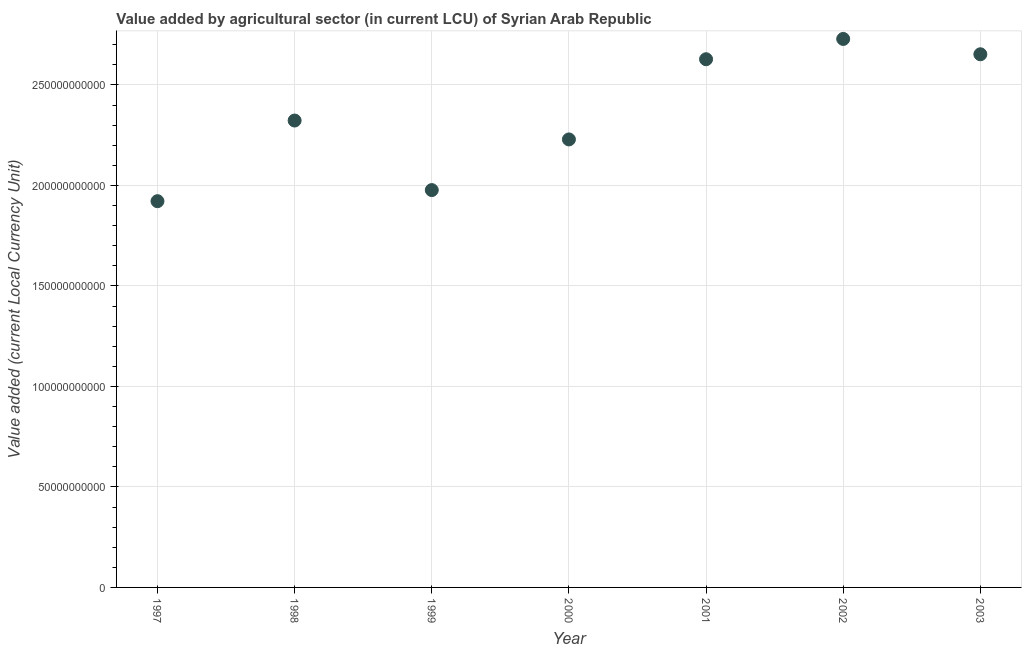What is the value added by agriculture sector in 2000?
Ensure brevity in your answer.  2.23e+11. Across all years, what is the maximum value added by agriculture sector?
Offer a very short reply. 2.73e+11. Across all years, what is the minimum value added by agriculture sector?
Your answer should be compact. 1.92e+11. In which year was the value added by agriculture sector maximum?
Provide a succinct answer. 2002. What is the sum of the value added by agriculture sector?
Make the answer very short. 1.65e+12. What is the difference between the value added by agriculture sector in 1998 and 2002?
Provide a short and direct response. -4.06e+1. What is the average value added by agriculture sector per year?
Keep it short and to the point. 2.35e+11. What is the median value added by agriculture sector?
Your response must be concise. 2.32e+11. In how many years, is the value added by agriculture sector greater than 260000000000 LCU?
Ensure brevity in your answer.  3. What is the ratio of the value added by agriculture sector in 1998 to that in 2001?
Offer a terse response. 0.88. Is the value added by agriculture sector in 2001 less than that in 2003?
Provide a succinct answer. Yes. Is the difference between the value added by agriculture sector in 1997 and 2002 greater than the difference between any two years?
Your answer should be compact. Yes. What is the difference between the highest and the second highest value added by agriculture sector?
Offer a very short reply. 7.63e+09. What is the difference between the highest and the lowest value added by agriculture sector?
Keep it short and to the point. 8.07e+1. Does the value added by agriculture sector monotonically increase over the years?
Make the answer very short. No. How many dotlines are there?
Offer a terse response. 1. Are the values on the major ticks of Y-axis written in scientific E-notation?
Offer a terse response. No. What is the title of the graph?
Provide a short and direct response. Value added by agricultural sector (in current LCU) of Syrian Arab Republic. What is the label or title of the Y-axis?
Provide a short and direct response. Value added (current Local Currency Unit). What is the Value added (current Local Currency Unit) in 1997?
Your answer should be compact. 1.92e+11. What is the Value added (current Local Currency Unit) in 1998?
Give a very brief answer. 2.32e+11. What is the Value added (current Local Currency Unit) in 1999?
Your answer should be compact. 1.98e+11. What is the Value added (current Local Currency Unit) in 2000?
Make the answer very short. 2.23e+11. What is the Value added (current Local Currency Unit) in 2001?
Ensure brevity in your answer.  2.63e+11. What is the Value added (current Local Currency Unit) in 2002?
Provide a short and direct response. 2.73e+11. What is the Value added (current Local Currency Unit) in 2003?
Keep it short and to the point. 2.65e+11. What is the difference between the Value added (current Local Currency Unit) in 1997 and 1998?
Give a very brief answer. -4.01e+1. What is the difference between the Value added (current Local Currency Unit) in 1997 and 1999?
Offer a terse response. -5.52e+09. What is the difference between the Value added (current Local Currency Unit) in 1997 and 2000?
Keep it short and to the point. -3.07e+1. What is the difference between the Value added (current Local Currency Unit) in 1997 and 2001?
Offer a very short reply. -7.06e+1. What is the difference between the Value added (current Local Currency Unit) in 1997 and 2002?
Ensure brevity in your answer.  -8.07e+1. What is the difference between the Value added (current Local Currency Unit) in 1997 and 2003?
Your answer should be compact. -7.31e+1. What is the difference between the Value added (current Local Currency Unit) in 1998 and 1999?
Ensure brevity in your answer.  3.46e+1. What is the difference between the Value added (current Local Currency Unit) in 1998 and 2000?
Provide a short and direct response. 9.40e+09. What is the difference between the Value added (current Local Currency Unit) in 1998 and 2001?
Offer a very short reply. -3.05e+1. What is the difference between the Value added (current Local Currency Unit) in 1998 and 2002?
Keep it short and to the point. -4.06e+1. What is the difference between the Value added (current Local Currency Unit) in 1998 and 2003?
Offer a very short reply. -3.30e+1. What is the difference between the Value added (current Local Currency Unit) in 1999 and 2000?
Make the answer very short. -2.52e+1. What is the difference between the Value added (current Local Currency Unit) in 1999 and 2001?
Offer a very short reply. -6.51e+1. What is the difference between the Value added (current Local Currency Unit) in 1999 and 2002?
Make the answer very short. -7.52e+1. What is the difference between the Value added (current Local Currency Unit) in 1999 and 2003?
Offer a very short reply. -6.76e+1. What is the difference between the Value added (current Local Currency Unit) in 2000 and 2001?
Give a very brief answer. -3.99e+1. What is the difference between the Value added (current Local Currency Unit) in 2000 and 2002?
Keep it short and to the point. -5.00e+1. What is the difference between the Value added (current Local Currency Unit) in 2000 and 2003?
Your answer should be compact. -4.24e+1. What is the difference between the Value added (current Local Currency Unit) in 2001 and 2002?
Ensure brevity in your answer.  -1.01e+1. What is the difference between the Value added (current Local Currency Unit) in 2001 and 2003?
Your response must be concise. -2.47e+09. What is the difference between the Value added (current Local Currency Unit) in 2002 and 2003?
Provide a short and direct response. 7.63e+09. What is the ratio of the Value added (current Local Currency Unit) in 1997 to that in 1998?
Provide a succinct answer. 0.83. What is the ratio of the Value added (current Local Currency Unit) in 1997 to that in 1999?
Give a very brief answer. 0.97. What is the ratio of the Value added (current Local Currency Unit) in 1997 to that in 2000?
Offer a very short reply. 0.86. What is the ratio of the Value added (current Local Currency Unit) in 1997 to that in 2001?
Keep it short and to the point. 0.73. What is the ratio of the Value added (current Local Currency Unit) in 1997 to that in 2002?
Give a very brief answer. 0.7. What is the ratio of the Value added (current Local Currency Unit) in 1997 to that in 2003?
Make the answer very short. 0.72. What is the ratio of the Value added (current Local Currency Unit) in 1998 to that in 1999?
Provide a succinct answer. 1.18. What is the ratio of the Value added (current Local Currency Unit) in 1998 to that in 2000?
Keep it short and to the point. 1.04. What is the ratio of the Value added (current Local Currency Unit) in 1998 to that in 2001?
Offer a terse response. 0.88. What is the ratio of the Value added (current Local Currency Unit) in 1998 to that in 2002?
Your response must be concise. 0.85. What is the ratio of the Value added (current Local Currency Unit) in 1998 to that in 2003?
Your answer should be very brief. 0.88. What is the ratio of the Value added (current Local Currency Unit) in 1999 to that in 2000?
Make the answer very short. 0.89. What is the ratio of the Value added (current Local Currency Unit) in 1999 to that in 2001?
Provide a short and direct response. 0.75. What is the ratio of the Value added (current Local Currency Unit) in 1999 to that in 2002?
Offer a very short reply. 0.72. What is the ratio of the Value added (current Local Currency Unit) in 1999 to that in 2003?
Ensure brevity in your answer.  0.74. What is the ratio of the Value added (current Local Currency Unit) in 2000 to that in 2001?
Provide a succinct answer. 0.85. What is the ratio of the Value added (current Local Currency Unit) in 2000 to that in 2002?
Keep it short and to the point. 0.82. What is the ratio of the Value added (current Local Currency Unit) in 2000 to that in 2003?
Make the answer very short. 0.84. What is the ratio of the Value added (current Local Currency Unit) in 2001 to that in 2003?
Give a very brief answer. 0.99. 